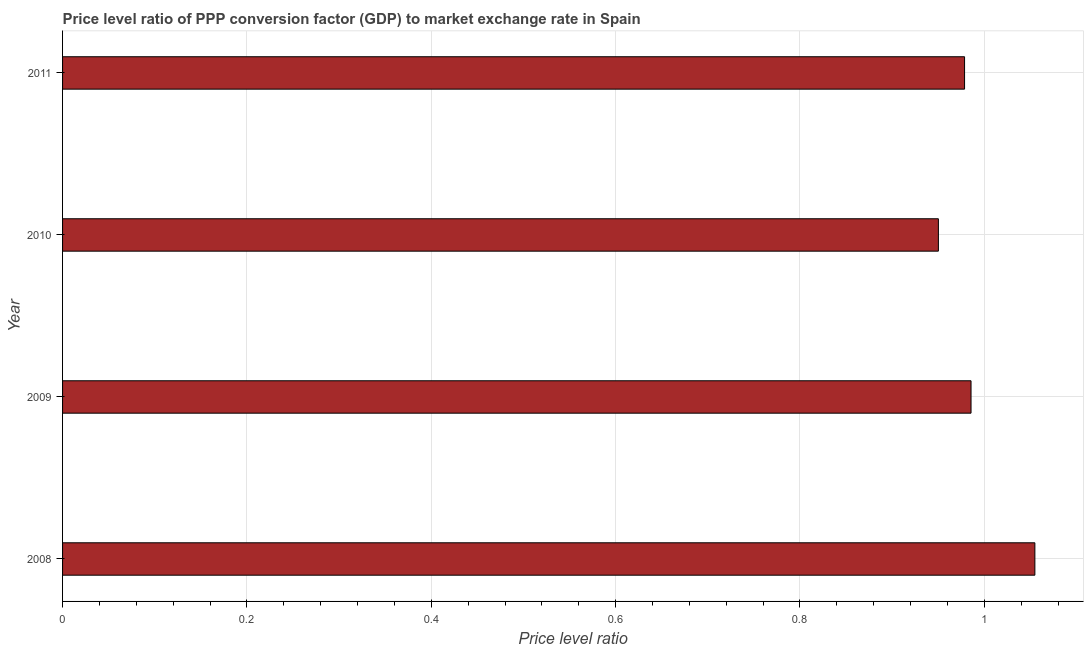Does the graph contain grids?
Your answer should be compact. Yes. What is the title of the graph?
Offer a terse response. Price level ratio of PPP conversion factor (GDP) to market exchange rate in Spain. What is the label or title of the X-axis?
Ensure brevity in your answer.  Price level ratio. What is the label or title of the Y-axis?
Ensure brevity in your answer.  Year. What is the price level ratio in 2009?
Provide a succinct answer. 0.99. Across all years, what is the maximum price level ratio?
Provide a short and direct response. 1.05. Across all years, what is the minimum price level ratio?
Your answer should be compact. 0.95. In which year was the price level ratio maximum?
Make the answer very short. 2008. In which year was the price level ratio minimum?
Make the answer very short. 2010. What is the sum of the price level ratio?
Offer a terse response. 3.97. What is the difference between the price level ratio in 2008 and 2009?
Ensure brevity in your answer.  0.07. What is the average price level ratio per year?
Ensure brevity in your answer.  0.99. What is the median price level ratio?
Your response must be concise. 0.98. In how many years, is the price level ratio greater than 0.4 ?
Ensure brevity in your answer.  4. Do a majority of the years between 2011 and 2010 (inclusive) have price level ratio greater than 0.72 ?
Make the answer very short. No. What is the ratio of the price level ratio in 2009 to that in 2011?
Your answer should be very brief. 1.01. What is the difference between the highest and the second highest price level ratio?
Provide a short and direct response. 0.07. Is the sum of the price level ratio in 2008 and 2009 greater than the maximum price level ratio across all years?
Your answer should be compact. Yes. How many bars are there?
Offer a very short reply. 4. How many years are there in the graph?
Provide a short and direct response. 4. Are the values on the major ticks of X-axis written in scientific E-notation?
Provide a short and direct response. No. What is the Price level ratio in 2008?
Your answer should be compact. 1.05. What is the Price level ratio in 2009?
Offer a terse response. 0.99. What is the Price level ratio of 2010?
Provide a short and direct response. 0.95. What is the Price level ratio in 2011?
Provide a succinct answer. 0.98. What is the difference between the Price level ratio in 2008 and 2009?
Give a very brief answer. 0.07. What is the difference between the Price level ratio in 2008 and 2010?
Offer a very short reply. 0.1. What is the difference between the Price level ratio in 2008 and 2011?
Your response must be concise. 0.08. What is the difference between the Price level ratio in 2009 and 2010?
Make the answer very short. 0.04. What is the difference between the Price level ratio in 2009 and 2011?
Ensure brevity in your answer.  0.01. What is the difference between the Price level ratio in 2010 and 2011?
Provide a short and direct response. -0.03. What is the ratio of the Price level ratio in 2008 to that in 2009?
Offer a very short reply. 1.07. What is the ratio of the Price level ratio in 2008 to that in 2010?
Your answer should be compact. 1.11. What is the ratio of the Price level ratio in 2008 to that in 2011?
Your answer should be compact. 1.08. What is the ratio of the Price level ratio in 2009 to that in 2010?
Make the answer very short. 1.04. What is the ratio of the Price level ratio in 2009 to that in 2011?
Your response must be concise. 1.01. What is the ratio of the Price level ratio in 2010 to that in 2011?
Provide a short and direct response. 0.97. 